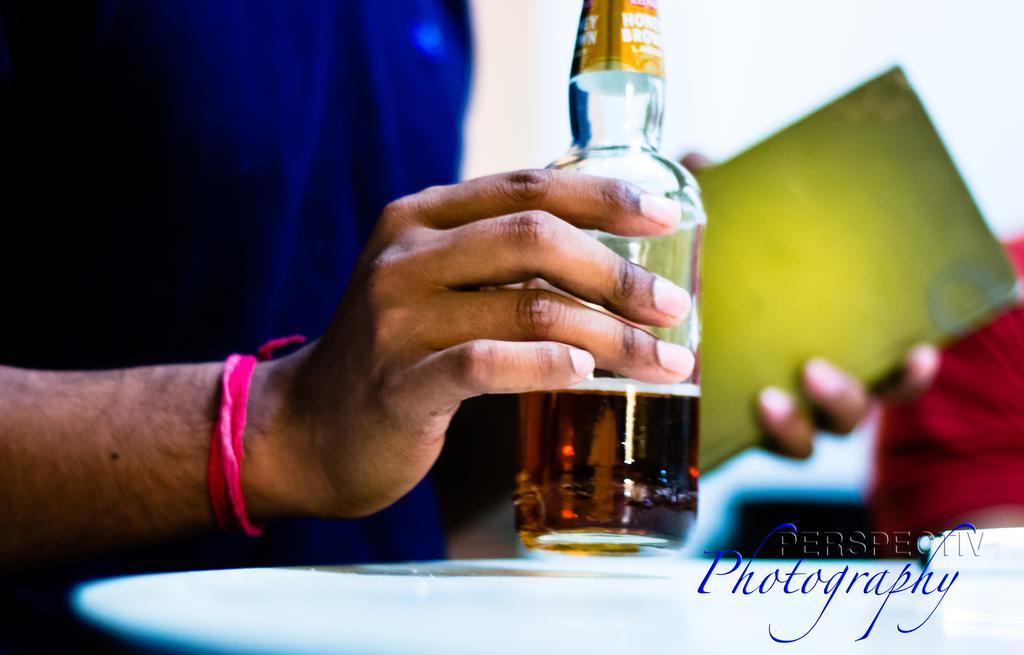<image>
Provide a brief description of the given image. Someone holds a bottle in one hand and a green book in the other, and the photographers logo appears on the image. 